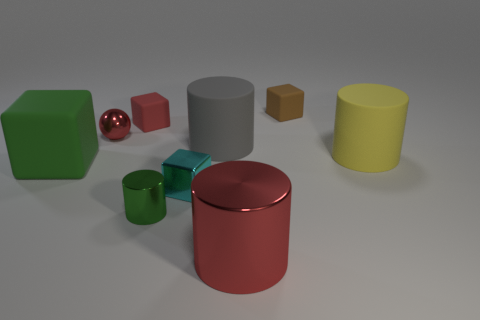Is the metallic ball the same size as the cyan metal thing?
Offer a terse response. Yes. There is a large cylinder that is the same material as the large gray thing; what color is it?
Your answer should be very brief. Yellow. The brown rubber thing that is the same size as the red block is what shape?
Your answer should be very brief. Cube. There is a cylinder that is the same size as the red metal sphere; what is its material?
Offer a terse response. Metal. Are there an equal number of brown rubber objects to the left of the red ball and small metal objects right of the large red metallic object?
Keep it short and to the point. Yes. What number of other objects are there of the same color as the tiny cylinder?
Provide a succinct answer. 1. Does the small rubber object that is to the right of the big metallic thing have the same shape as the big metallic object?
Provide a succinct answer. No. What is the material of the big gray thing that is the same shape as the tiny green metal object?
Your answer should be very brief. Rubber. Are there any other things that are the same size as the red metal ball?
Give a very brief answer. Yes. Is there a red block?
Give a very brief answer. Yes. 